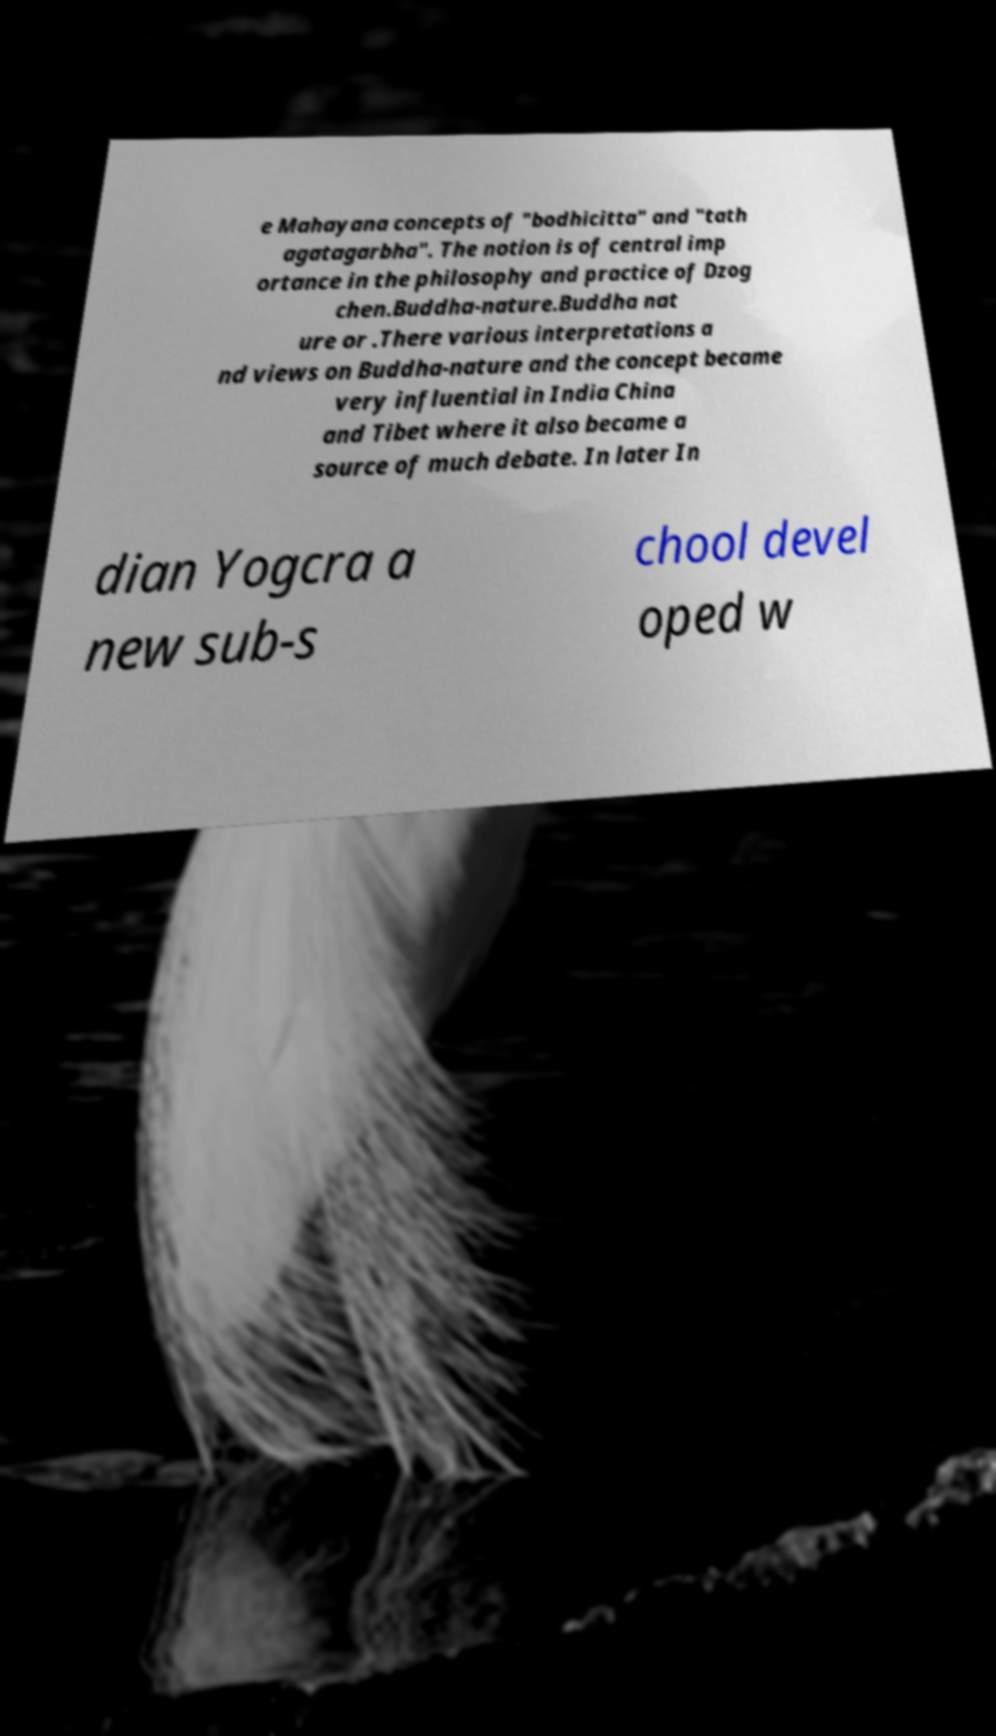What messages or text are displayed in this image? I need them in a readable, typed format. e Mahayana concepts of "bodhicitta" and "tath agatagarbha". The notion is of central imp ortance in the philosophy and practice of Dzog chen.Buddha-nature.Buddha nat ure or .There various interpretations a nd views on Buddha-nature and the concept became very influential in India China and Tibet where it also became a source of much debate. In later In dian Yogcra a new sub-s chool devel oped w 